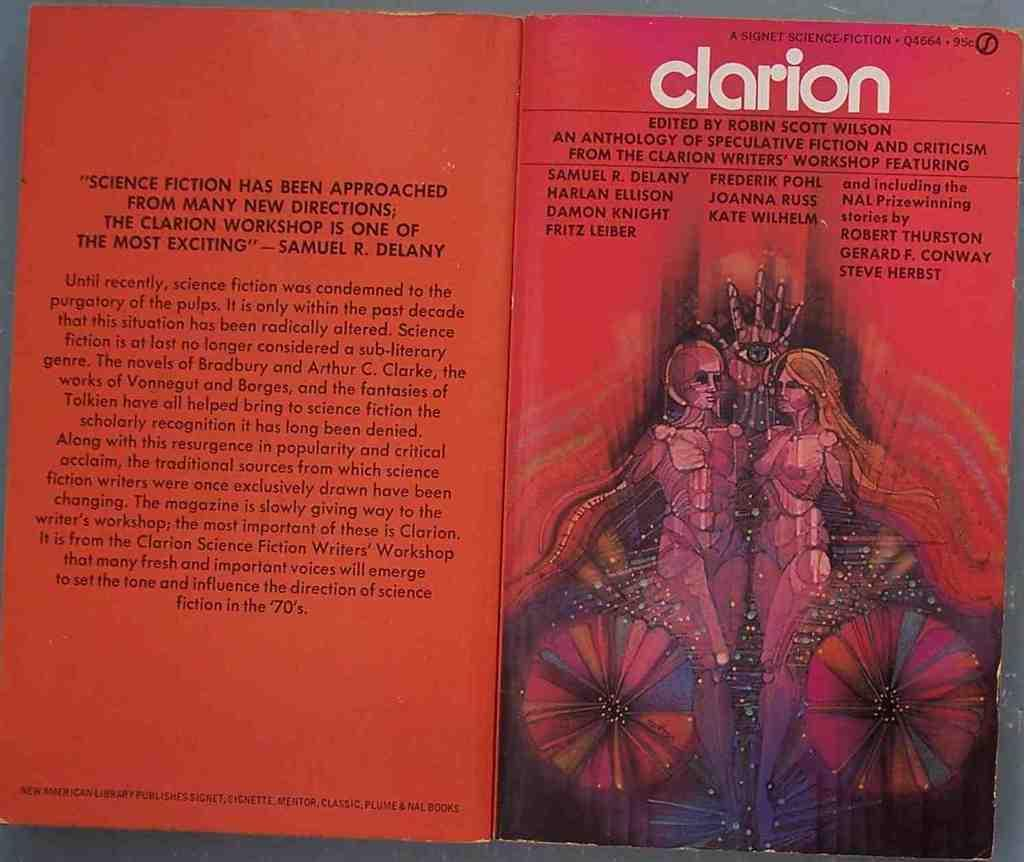<image>
Relay a brief, clear account of the picture shown. The science fiction book shown is called Clarion. 